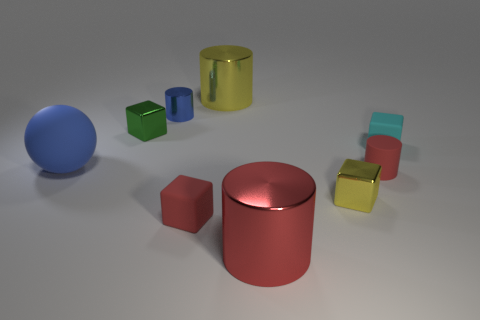Add 1 tiny blue shiny things. How many objects exist? 10 Subtract all cubes. How many objects are left? 5 Subtract 0 purple balls. How many objects are left? 9 Subtract all tiny blue things. Subtract all rubber blocks. How many objects are left? 6 Add 1 cyan rubber objects. How many cyan rubber objects are left? 2 Add 7 tiny green matte spheres. How many tiny green matte spheres exist? 7 